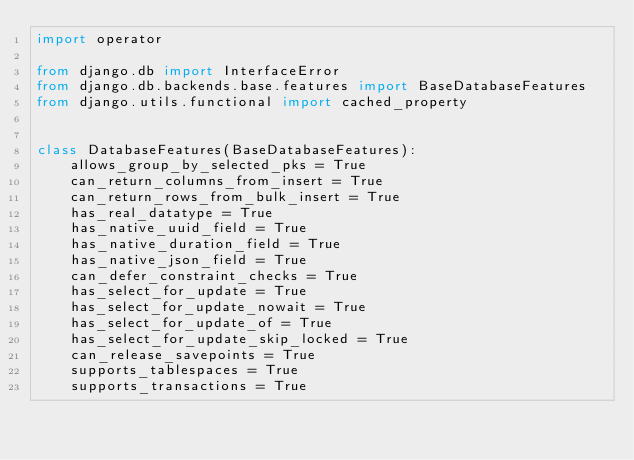Convert code to text. <code><loc_0><loc_0><loc_500><loc_500><_Python_>import operator

from django.db import InterfaceError
from django.db.backends.base.features import BaseDatabaseFeatures
from django.utils.functional import cached_property


class DatabaseFeatures(BaseDatabaseFeatures):
    allows_group_by_selected_pks = True
    can_return_columns_from_insert = True
    can_return_rows_from_bulk_insert = True
    has_real_datatype = True
    has_native_uuid_field = True
    has_native_duration_field = True
    has_native_json_field = True
    can_defer_constraint_checks = True
    has_select_for_update = True
    has_select_for_update_nowait = True
    has_select_for_update_of = True
    has_select_for_update_skip_locked = True
    can_release_savepoints = True
    supports_tablespaces = True
    supports_transactions = True</code> 